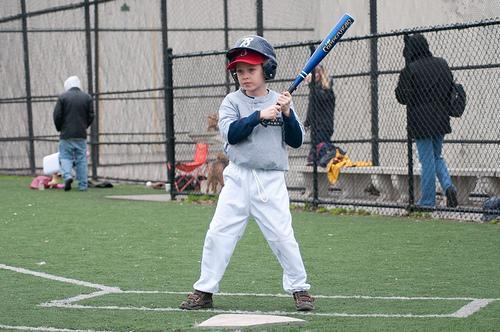How many dogs are in the picture?
Give a very brief answer. 1. How many people are there?
Give a very brief answer. 4. 